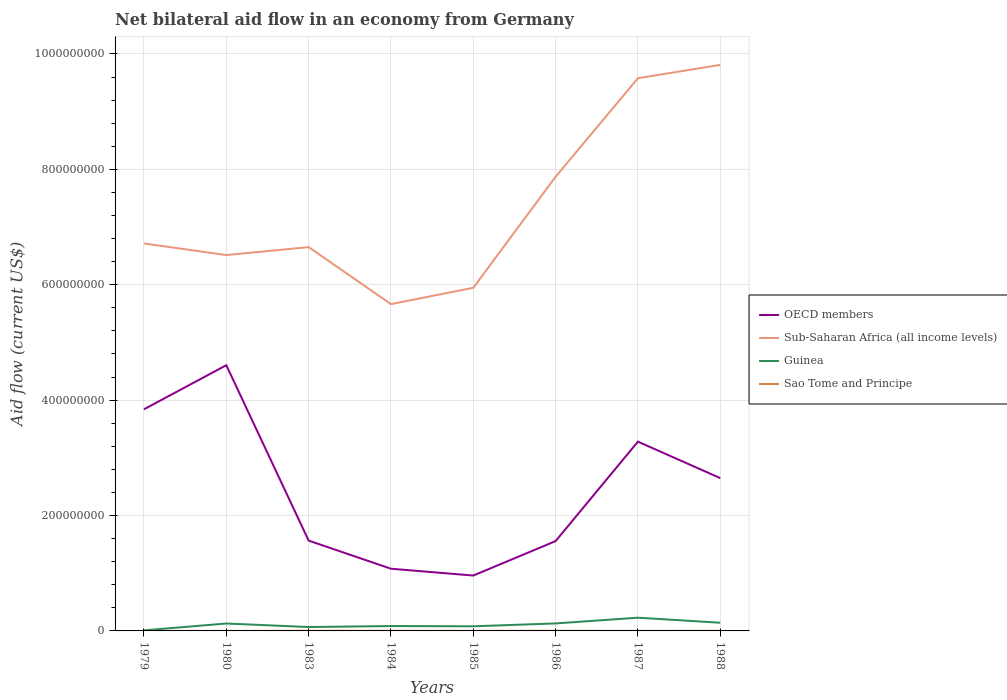How many different coloured lines are there?
Your answer should be compact. 4. Is the number of lines equal to the number of legend labels?
Keep it short and to the point. Yes. Across all years, what is the maximum net bilateral aid flow in Sub-Saharan Africa (all income levels)?
Your answer should be very brief. 5.66e+08. What is the total net bilateral aid flow in Sao Tome and Principe in the graph?
Offer a very short reply. -8.00e+04. What is the difference between the highest and the second highest net bilateral aid flow in Sao Tome and Principe?
Make the answer very short. 2.60e+05. How many lines are there?
Offer a terse response. 4. What is the difference between two consecutive major ticks on the Y-axis?
Offer a very short reply. 2.00e+08. Are the values on the major ticks of Y-axis written in scientific E-notation?
Offer a very short reply. No. Does the graph contain any zero values?
Offer a very short reply. No. Where does the legend appear in the graph?
Ensure brevity in your answer.  Center right. What is the title of the graph?
Offer a very short reply. Net bilateral aid flow in an economy from Germany. What is the Aid flow (current US$) in OECD members in 1979?
Offer a terse response. 3.84e+08. What is the Aid flow (current US$) in Sub-Saharan Africa (all income levels) in 1979?
Give a very brief answer. 6.71e+08. What is the Aid flow (current US$) in Sao Tome and Principe in 1979?
Provide a short and direct response. 4.00e+04. What is the Aid flow (current US$) in OECD members in 1980?
Provide a short and direct response. 4.61e+08. What is the Aid flow (current US$) in Sub-Saharan Africa (all income levels) in 1980?
Keep it short and to the point. 6.51e+08. What is the Aid flow (current US$) in Guinea in 1980?
Give a very brief answer. 1.28e+07. What is the Aid flow (current US$) in Sao Tome and Principe in 1980?
Your answer should be compact. 6.00e+04. What is the Aid flow (current US$) in OECD members in 1983?
Your answer should be very brief. 1.57e+08. What is the Aid flow (current US$) in Sub-Saharan Africa (all income levels) in 1983?
Provide a succinct answer. 6.65e+08. What is the Aid flow (current US$) of Guinea in 1983?
Ensure brevity in your answer.  6.73e+06. What is the Aid flow (current US$) of Sao Tome and Principe in 1983?
Offer a very short reply. 2.20e+05. What is the Aid flow (current US$) in OECD members in 1984?
Your answer should be compact. 1.08e+08. What is the Aid flow (current US$) of Sub-Saharan Africa (all income levels) in 1984?
Ensure brevity in your answer.  5.66e+08. What is the Aid flow (current US$) of Guinea in 1984?
Provide a succinct answer. 8.46e+06. What is the Aid flow (current US$) in Sao Tome and Principe in 1984?
Your response must be concise. 2.50e+05. What is the Aid flow (current US$) in OECD members in 1985?
Provide a succinct answer. 9.60e+07. What is the Aid flow (current US$) of Sub-Saharan Africa (all income levels) in 1985?
Make the answer very short. 5.95e+08. What is the Aid flow (current US$) in Guinea in 1985?
Provide a short and direct response. 8.01e+06. What is the Aid flow (current US$) of Sao Tome and Principe in 1985?
Provide a short and direct response. 9.00e+04. What is the Aid flow (current US$) of OECD members in 1986?
Offer a terse response. 1.56e+08. What is the Aid flow (current US$) of Sub-Saharan Africa (all income levels) in 1986?
Give a very brief answer. 7.87e+08. What is the Aid flow (current US$) of Guinea in 1986?
Ensure brevity in your answer.  1.30e+07. What is the Aid flow (current US$) of OECD members in 1987?
Your answer should be compact. 3.28e+08. What is the Aid flow (current US$) in Sub-Saharan Africa (all income levels) in 1987?
Your answer should be very brief. 9.58e+08. What is the Aid flow (current US$) of Guinea in 1987?
Offer a terse response. 2.29e+07. What is the Aid flow (current US$) of OECD members in 1988?
Give a very brief answer. 2.65e+08. What is the Aid flow (current US$) of Sub-Saharan Africa (all income levels) in 1988?
Give a very brief answer. 9.81e+08. What is the Aid flow (current US$) in Guinea in 1988?
Make the answer very short. 1.42e+07. What is the Aid flow (current US$) in Sao Tome and Principe in 1988?
Your response must be concise. 3.00e+05. Across all years, what is the maximum Aid flow (current US$) of OECD members?
Provide a short and direct response. 4.61e+08. Across all years, what is the maximum Aid flow (current US$) of Sub-Saharan Africa (all income levels)?
Offer a terse response. 9.81e+08. Across all years, what is the maximum Aid flow (current US$) of Guinea?
Your answer should be compact. 2.29e+07. Across all years, what is the maximum Aid flow (current US$) of Sao Tome and Principe?
Provide a succinct answer. 3.00e+05. Across all years, what is the minimum Aid flow (current US$) in OECD members?
Offer a very short reply. 9.60e+07. Across all years, what is the minimum Aid flow (current US$) of Sub-Saharan Africa (all income levels)?
Your answer should be compact. 5.66e+08. Across all years, what is the minimum Aid flow (current US$) in Sao Tome and Principe?
Provide a succinct answer. 4.00e+04. What is the total Aid flow (current US$) in OECD members in the graph?
Provide a succinct answer. 1.95e+09. What is the total Aid flow (current US$) in Sub-Saharan Africa (all income levels) in the graph?
Provide a short and direct response. 5.88e+09. What is the total Aid flow (current US$) of Guinea in the graph?
Your response must be concise. 8.72e+07. What is the total Aid flow (current US$) of Sao Tome and Principe in the graph?
Give a very brief answer. 1.29e+06. What is the difference between the Aid flow (current US$) of OECD members in 1979 and that in 1980?
Your answer should be very brief. -7.64e+07. What is the difference between the Aid flow (current US$) of Sub-Saharan Africa (all income levels) in 1979 and that in 1980?
Your response must be concise. 2.01e+07. What is the difference between the Aid flow (current US$) of Guinea in 1979 and that in 1980?
Your response must be concise. -1.18e+07. What is the difference between the Aid flow (current US$) of OECD members in 1979 and that in 1983?
Your answer should be compact. 2.28e+08. What is the difference between the Aid flow (current US$) in Sub-Saharan Africa (all income levels) in 1979 and that in 1983?
Offer a very short reply. 6.29e+06. What is the difference between the Aid flow (current US$) of Guinea in 1979 and that in 1983?
Provide a succinct answer. -5.73e+06. What is the difference between the Aid flow (current US$) of OECD members in 1979 and that in 1984?
Make the answer very short. 2.76e+08. What is the difference between the Aid flow (current US$) of Sub-Saharan Africa (all income levels) in 1979 and that in 1984?
Ensure brevity in your answer.  1.05e+08. What is the difference between the Aid flow (current US$) in Guinea in 1979 and that in 1984?
Offer a terse response. -7.46e+06. What is the difference between the Aid flow (current US$) in OECD members in 1979 and that in 1985?
Offer a terse response. 2.88e+08. What is the difference between the Aid flow (current US$) of Sub-Saharan Africa (all income levels) in 1979 and that in 1985?
Your answer should be very brief. 7.68e+07. What is the difference between the Aid flow (current US$) in Guinea in 1979 and that in 1985?
Provide a succinct answer. -7.01e+06. What is the difference between the Aid flow (current US$) of Sao Tome and Principe in 1979 and that in 1985?
Keep it short and to the point. -5.00e+04. What is the difference between the Aid flow (current US$) in OECD members in 1979 and that in 1986?
Ensure brevity in your answer.  2.28e+08. What is the difference between the Aid flow (current US$) of Sub-Saharan Africa (all income levels) in 1979 and that in 1986?
Your response must be concise. -1.16e+08. What is the difference between the Aid flow (current US$) in Guinea in 1979 and that in 1986?
Provide a succinct answer. -1.20e+07. What is the difference between the Aid flow (current US$) in OECD members in 1979 and that in 1987?
Offer a terse response. 5.61e+07. What is the difference between the Aid flow (current US$) of Sub-Saharan Africa (all income levels) in 1979 and that in 1987?
Provide a short and direct response. -2.86e+08. What is the difference between the Aid flow (current US$) in Guinea in 1979 and that in 1987?
Ensure brevity in your answer.  -2.19e+07. What is the difference between the Aid flow (current US$) of OECD members in 1979 and that in 1988?
Give a very brief answer. 1.19e+08. What is the difference between the Aid flow (current US$) in Sub-Saharan Africa (all income levels) in 1979 and that in 1988?
Provide a short and direct response. -3.10e+08. What is the difference between the Aid flow (current US$) of Guinea in 1979 and that in 1988?
Give a very brief answer. -1.32e+07. What is the difference between the Aid flow (current US$) of Sao Tome and Principe in 1979 and that in 1988?
Provide a succinct answer. -2.60e+05. What is the difference between the Aid flow (current US$) of OECD members in 1980 and that in 1983?
Your answer should be compact. 3.04e+08. What is the difference between the Aid flow (current US$) of Sub-Saharan Africa (all income levels) in 1980 and that in 1983?
Give a very brief answer. -1.38e+07. What is the difference between the Aid flow (current US$) in Guinea in 1980 and that in 1983?
Make the answer very short. 6.12e+06. What is the difference between the Aid flow (current US$) of Sao Tome and Principe in 1980 and that in 1983?
Provide a succinct answer. -1.60e+05. What is the difference between the Aid flow (current US$) in OECD members in 1980 and that in 1984?
Give a very brief answer. 3.53e+08. What is the difference between the Aid flow (current US$) of Sub-Saharan Africa (all income levels) in 1980 and that in 1984?
Offer a very short reply. 8.50e+07. What is the difference between the Aid flow (current US$) in Guinea in 1980 and that in 1984?
Your response must be concise. 4.39e+06. What is the difference between the Aid flow (current US$) in Sao Tome and Principe in 1980 and that in 1984?
Provide a short and direct response. -1.90e+05. What is the difference between the Aid flow (current US$) in OECD members in 1980 and that in 1985?
Keep it short and to the point. 3.65e+08. What is the difference between the Aid flow (current US$) in Sub-Saharan Africa (all income levels) in 1980 and that in 1985?
Make the answer very short. 5.67e+07. What is the difference between the Aid flow (current US$) of Guinea in 1980 and that in 1985?
Provide a short and direct response. 4.84e+06. What is the difference between the Aid flow (current US$) of Sao Tome and Principe in 1980 and that in 1985?
Ensure brevity in your answer.  -3.00e+04. What is the difference between the Aid flow (current US$) in OECD members in 1980 and that in 1986?
Provide a short and direct response. 3.05e+08. What is the difference between the Aid flow (current US$) of Sub-Saharan Africa (all income levels) in 1980 and that in 1986?
Give a very brief answer. -1.36e+08. What is the difference between the Aid flow (current US$) in OECD members in 1980 and that in 1987?
Ensure brevity in your answer.  1.32e+08. What is the difference between the Aid flow (current US$) of Sub-Saharan Africa (all income levels) in 1980 and that in 1987?
Provide a succinct answer. -3.07e+08. What is the difference between the Aid flow (current US$) of Guinea in 1980 and that in 1987?
Keep it short and to the point. -1.01e+07. What is the difference between the Aid flow (current US$) of OECD members in 1980 and that in 1988?
Ensure brevity in your answer.  1.96e+08. What is the difference between the Aid flow (current US$) in Sub-Saharan Africa (all income levels) in 1980 and that in 1988?
Ensure brevity in your answer.  -3.30e+08. What is the difference between the Aid flow (current US$) in Guinea in 1980 and that in 1988?
Give a very brief answer. -1.35e+06. What is the difference between the Aid flow (current US$) of Sao Tome and Principe in 1980 and that in 1988?
Your response must be concise. -2.40e+05. What is the difference between the Aid flow (current US$) of OECD members in 1983 and that in 1984?
Provide a short and direct response. 4.87e+07. What is the difference between the Aid flow (current US$) of Sub-Saharan Africa (all income levels) in 1983 and that in 1984?
Your answer should be compact. 9.88e+07. What is the difference between the Aid flow (current US$) in Guinea in 1983 and that in 1984?
Your answer should be very brief. -1.73e+06. What is the difference between the Aid flow (current US$) in OECD members in 1983 and that in 1985?
Your response must be concise. 6.06e+07. What is the difference between the Aid flow (current US$) of Sub-Saharan Africa (all income levels) in 1983 and that in 1985?
Provide a short and direct response. 7.05e+07. What is the difference between the Aid flow (current US$) in Guinea in 1983 and that in 1985?
Your answer should be compact. -1.28e+06. What is the difference between the Aid flow (current US$) in Sao Tome and Principe in 1983 and that in 1985?
Offer a very short reply. 1.30e+05. What is the difference between the Aid flow (current US$) in OECD members in 1983 and that in 1986?
Your answer should be very brief. 8.70e+05. What is the difference between the Aid flow (current US$) of Sub-Saharan Africa (all income levels) in 1983 and that in 1986?
Your answer should be compact. -1.22e+08. What is the difference between the Aid flow (current US$) of Guinea in 1983 and that in 1986?
Make the answer very short. -6.25e+06. What is the difference between the Aid flow (current US$) of OECD members in 1983 and that in 1987?
Ensure brevity in your answer.  -1.72e+08. What is the difference between the Aid flow (current US$) in Sub-Saharan Africa (all income levels) in 1983 and that in 1987?
Keep it short and to the point. -2.93e+08. What is the difference between the Aid flow (current US$) of Guinea in 1983 and that in 1987?
Keep it short and to the point. -1.62e+07. What is the difference between the Aid flow (current US$) in Sao Tome and Principe in 1983 and that in 1987?
Keep it short and to the point. 1.70e+05. What is the difference between the Aid flow (current US$) of OECD members in 1983 and that in 1988?
Provide a short and direct response. -1.08e+08. What is the difference between the Aid flow (current US$) of Sub-Saharan Africa (all income levels) in 1983 and that in 1988?
Make the answer very short. -3.16e+08. What is the difference between the Aid flow (current US$) in Guinea in 1983 and that in 1988?
Your response must be concise. -7.47e+06. What is the difference between the Aid flow (current US$) of Sao Tome and Principe in 1983 and that in 1988?
Your answer should be very brief. -8.00e+04. What is the difference between the Aid flow (current US$) of OECD members in 1984 and that in 1985?
Offer a very short reply. 1.18e+07. What is the difference between the Aid flow (current US$) of Sub-Saharan Africa (all income levels) in 1984 and that in 1985?
Provide a short and direct response. -2.82e+07. What is the difference between the Aid flow (current US$) in Sao Tome and Principe in 1984 and that in 1985?
Your response must be concise. 1.60e+05. What is the difference between the Aid flow (current US$) of OECD members in 1984 and that in 1986?
Provide a succinct answer. -4.79e+07. What is the difference between the Aid flow (current US$) in Sub-Saharan Africa (all income levels) in 1984 and that in 1986?
Your response must be concise. -2.21e+08. What is the difference between the Aid flow (current US$) of Guinea in 1984 and that in 1986?
Offer a very short reply. -4.52e+06. What is the difference between the Aid flow (current US$) of Sao Tome and Principe in 1984 and that in 1986?
Your response must be concise. -3.00e+04. What is the difference between the Aid flow (current US$) of OECD members in 1984 and that in 1987?
Offer a terse response. -2.20e+08. What is the difference between the Aid flow (current US$) of Sub-Saharan Africa (all income levels) in 1984 and that in 1987?
Offer a terse response. -3.92e+08. What is the difference between the Aid flow (current US$) of Guinea in 1984 and that in 1987?
Offer a very short reply. -1.45e+07. What is the difference between the Aid flow (current US$) in OECD members in 1984 and that in 1988?
Your answer should be compact. -1.57e+08. What is the difference between the Aid flow (current US$) of Sub-Saharan Africa (all income levels) in 1984 and that in 1988?
Make the answer very short. -4.15e+08. What is the difference between the Aid flow (current US$) of Guinea in 1984 and that in 1988?
Offer a very short reply. -5.74e+06. What is the difference between the Aid flow (current US$) in OECD members in 1985 and that in 1986?
Your answer should be very brief. -5.97e+07. What is the difference between the Aid flow (current US$) of Sub-Saharan Africa (all income levels) in 1985 and that in 1986?
Keep it short and to the point. -1.93e+08. What is the difference between the Aid flow (current US$) of Guinea in 1985 and that in 1986?
Provide a succinct answer. -4.97e+06. What is the difference between the Aid flow (current US$) of OECD members in 1985 and that in 1987?
Your response must be concise. -2.32e+08. What is the difference between the Aid flow (current US$) of Sub-Saharan Africa (all income levels) in 1985 and that in 1987?
Make the answer very short. -3.63e+08. What is the difference between the Aid flow (current US$) of Guinea in 1985 and that in 1987?
Keep it short and to the point. -1.49e+07. What is the difference between the Aid flow (current US$) in OECD members in 1985 and that in 1988?
Give a very brief answer. -1.69e+08. What is the difference between the Aid flow (current US$) in Sub-Saharan Africa (all income levels) in 1985 and that in 1988?
Your answer should be very brief. -3.86e+08. What is the difference between the Aid flow (current US$) in Guinea in 1985 and that in 1988?
Provide a short and direct response. -6.19e+06. What is the difference between the Aid flow (current US$) in OECD members in 1986 and that in 1987?
Your answer should be compact. -1.72e+08. What is the difference between the Aid flow (current US$) in Sub-Saharan Africa (all income levels) in 1986 and that in 1987?
Your answer should be very brief. -1.71e+08. What is the difference between the Aid flow (current US$) in Guinea in 1986 and that in 1987?
Offer a very short reply. -9.94e+06. What is the difference between the Aid flow (current US$) in OECD members in 1986 and that in 1988?
Offer a terse response. -1.09e+08. What is the difference between the Aid flow (current US$) in Sub-Saharan Africa (all income levels) in 1986 and that in 1988?
Your answer should be very brief. -1.94e+08. What is the difference between the Aid flow (current US$) of Guinea in 1986 and that in 1988?
Keep it short and to the point. -1.22e+06. What is the difference between the Aid flow (current US$) of Sao Tome and Principe in 1986 and that in 1988?
Keep it short and to the point. -2.00e+04. What is the difference between the Aid flow (current US$) of OECD members in 1987 and that in 1988?
Your response must be concise. 6.32e+07. What is the difference between the Aid flow (current US$) in Sub-Saharan Africa (all income levels) in 1987 and that in 1988?
Make the answer very short. -2.31e+07. What is the difference between the Aid flow (current US$) of Guinea in 1987 and that in 1988?
Provide a short and direct response. 8.72e+06. What is the difference between the Aid flow (current US$) of OECD members in 1979 and the Aid flow (current US$) of Sub-Saharan Africa (all income levels) in 1980?
Offer a very short reply. -2.67e+08. What is the difference between the Aid flow (current US$) of OECD members in 1979 and the Aid flow (current US$) of Guinea in 1980?
Give a very brief answer. 3.71e+08. What is the difference between the Aid flow (current US$) in OECD members in 1979 and the Aid flow (current US$) in Sao Tome and Principe in 1980?
Keep it short and to the point. 3.84e+08. What is the difference between the Aid flow (current US$) in Sub-Saharan Africa (all income levels) in 1979 and the Aid flow (current US$) in Guinea in 1980?
Your response must be concise. 6.59e+08. What is the difference between the Aid flow (current US$) of Sub-Saharan Africa (all income levels) in 1979 and the Aid flow (current US$) of Sao Tome and Principe in 1980?
Your answer should be compact. 6.71e+08. What is the difference between the Aid flow (current US$) in Guinea in 1979 and the Aid flow (current US$) in Sao Tome and Principe in 1980?
Your answer should be very brief. 9.40e+05. What is the difference between the Aid flow (current US$) of OECD members in 1979 and the Aid flow (current US$) of Sub-Saharan Africa (all income levels) in 1983?
Your response must be concise. -2.81e+08. What is the difference between the Aid flow (current US$) in OECD members in 1979 and the Aid flow (current US$) in Guinea in 1983?
Offer a terse response. 3.77e+08. What is the difference between the Aid flow (current US$) in OECD members in 1979 and the Aid flow (current US$) in Sao Tome and Principe in 1983?
Your answer should be very brief. 3.84e+08. What is the difference between the Aid flow (current US$) of Sub-Saharan Africa (all income levels) in 1979 and the Aid flow (current US$) of Guinea in 1983?
Keep it short and to the point. 6.65e+08. What is the difference between the Aid flow (current US$) of Sub-Saharan Africa (all income levels) in 1979 and the Aid flow (current US$) of Sao Tome and Principe in 1983?
Offer a very short reply. 6.71e+08. What is the difference between the Aid flow (current US$) of Guinea in 1979 and the Aid flow (current US$) of Sao Tome and Principe in 1983?
Your answer should be very brief. 7.80e+05. What is the difference between the Aid flow (current US$) of OECD members in 1979 and the Aid flow (current US$) of Sub-Saharan Africa (all income levels) in 1984?
Your answer should be compact. -1.82e+08. What is the difference between the Aid flow (current US$) of OECD members in 1979 and the Aid flow (current US$) of Guinea in 1984?
Your response must be concise. 3.76e+08. What is the difference between the Aid flow (current US$) of OECD members in 1979 and the Aid flow (current US$) of Sao Tome and Principe in 1984?
Offer a terse response. 3.84e+08. What is the difference between the Aid flow (current US$) of Sub-Saharan Africa (all income levels) in 1979 and the Aid flow (current US$) of Guinea in 1984?
Offer a very short reply. 6.63e+08. What is the difference between the Aid flow (current US$) of Sub-Saharan Africa (all income levels) in 1979 and the Aid flow (current US$) of Sao Tome and Principe in 1984?
Your response must be concise. 6.71e+08. What is the difference between the Aid flow (current US$) in Guinea in 1979 and the Aid flow (current US$) in Sao Tome and Principe in 1984?
Provide a succinct answer. 7.50e+05. What is the difference between the Aid flow (current US$) in OECD members in 1979 and the Aid flow (current US$) in Sub-Saharan Africa (all income levels) in 1985?
Offer a terse response. -2.11e+08. What is the difference between the Aid flow (current US$) in OECD members in 1979 and the Aid flow (current US$) in Guinea in 1985?
Give a very brief answer. 3.76e+08. What is the difference between the Aid flow (current US$) in OECD members in 1979 and the Aid flow (current US$) in Sao Tome and Principe in 1985?
Provide a short and direct response. 3.84e+08. What is the difference between the Aid flow (current US$) of Sub-Saharan Africa (all income levels) in 1979 and the Aid flow (current US$) of Guinea in 1985?
Make the answer very short. 6.63e+08. What is the difference between the Aid flow (current US$) of Sub-Saharan Africa (all income levels) in 1979 and the Aid flow (current US$) of Sao Tome and Principe in 1985?
Make the answer very short. 6.71e+08. What is the difference between the Aid flow (current US$) of Guinea in 1979 and the Aid flow (current US$) of Sao Tome and Principe in 1985?
Provide a short and direct response. 9.10e+05. What is the difference between the Aid flow (current US$) of OECD members in 1979 and the Aid flow (current US$) of Sub-Saharan Africa (all income levels) in 1986?
Give a very brief answer. -4.03e+08. What is the difference between the Aid flow (current US$) in OECD members in 1979 and the Aid flow (current US$) in Guinea in 1986?
Keep it short and to the point. 3.71e+08. What is the difference between the Aid flow (current US$) of OECD members in 1979 and the Aid flow (current US$) of Sao Tome and Principe in 1986?
Your answer should be very brief. 3.84e+08. What is the difference between the Aid flow (current US$) of Sub-Saharan Africa (all income levels) in 1979 and the Aid flow (current US$) of Guinea in 1986?
Ensure brevity in your answer.  6.59e+08. What is the difference between the Aid flow (current US$) in Sub-Saharan Africa (all income levels) in 1979 and the Aid flow (current US$) in Sao Tome and Principe in 1986?
Provide a succinct answer. 6.71e+08. What is the difference between the Aid flow (current US$) of Guinea in 1979 and the Aid flow (current US$) of Sao Tome and Principe in 1986?
Ensure brevity in your answer.  7.20e+05. What is the difference between the Aid flow (current US$) of OECD members in 1979 and the Aid flow (current US$) of Sub-Saharan Africa (all income levels) in 1987?
Offer a very short reply. -5.74e+08. What is the difference between the Aid flow (current US$) in OECD members in 1979 and the Aid flow (current US$) in Guinea in 1987?
Make the answer very short. 3.61e+08. What is the difference between the Aid flow (current US$) of OECD members in 1979 and the Aid flow (current US$) of Sao Tome and Principe in 1987?
Give a very brief answer. 3.84e+08. What is the difference between the Aid flow (current US$) of Sub-Saharan Africa (all income levels) in 1979 and the Aid flow (current US$) of Guinea in 1987?
Offer a very short reply. 6.49e+08. What is the difference between the Aid flow (current US$) in Sub-Saharan Africa (all income levels) in 1979 and the Aid flow (current US$) in Sao Tome and Principe in 1987?
Your answer should be very brief. 6.71e+08. What is the difference between the Aid flow (current US$) of Guinea in 1979 and the Aid flow (current US$) of Sao Tome and Principe in 1987?
Keep it short and to the point. 9.50e+05. What is the difference between the Aid flow (current US$) in OECD members in 1979 and the Aid flow (current US$) in Sub-Saharan Africa (all income levels) in 1988?
Your answer should be very brief. -5.97e+08. What is the difference between the Aid flow (current US$) in OECD members in 1979 and the Aid flow (current US$) in Guinea in 1988?
Make the answer very short. 3.70e+08. What is the difference between the Aid flow (current US$) of OECD members in 1979 and the Aid flow (current US$) of Sao Tome and Principe in 1988?
Provide a succinct answer. 3.84e+08. What is the difference between the Aid flow (current US$) in Sub-Saharan Africa (all income levels) in 1979 and the Aid flow (current US$) in Guinea in 1988?
Your answer should be compact. 6.57e+08. What is the difference between the Aid flow (current US$) of Sub-Saharan Africa (all income levels) in 1979 and the Aid flow (current US$) of Sao Tome and Principe in 1988?
Offer a very short reply. 6.71e+08. What is the difference between the Aid flow (current US$) of Guinea in 1979 and the Aid flow (current US$) of Sao Tome and Principe in 1988?
Make the answer very short. 7.00e+05. What is the difference between the Aid flow (current US$) in OECD members in 1980 and the Aid flow (current US$) in Sub-Saharan Africa (all income levels) in 1983?
Your answer should be very brief. -2.05e+08. What is the difference between the Aid flow (current US$) in OECD members in 1980 and the Aid flow (current US$) in Guinea in 1983?
Give a very brief answer. 4.54e+08. What is the difference between the Aid flow (current US$) in OECD members in 1980 and the Aid flow (current US$) in Sao Tome and Principe in 1983?
Your answer should be very brief. 4.60e+08. What is the difference between the Aid flow (current US$) of Sub-Saharan Africa (all income levels) in 1980 and the Aid flow (current US$) of Guinea in 1983?
Your answer should be compact. 6.45e+08. What is the difference between the Aid flow (current US$) of Sub-Saharan Africa (all income levels) in 1980 and the Aid flow (current US$) of Sao Tome and Principe in 1983?
Keep it short and to the point. 6.51e+08. What is the difference between the Aid flow (current US$) of Guinea in 1980 and the Aid flow (current US$) of Sao Tome and Principe in 1983?
Give a very brief answer. 1.26e+07. What is the difference between the Aid flow (current US$) of OECD members in 1980 and the Aid flow (current US$) of Sub-Saharan Africa (all income levels) in 1984?
Your answer should be very brief. -1.06e+08. What is the difference between the Aid flow (current US$) of OECD members in 1980 and the Aid flow (current US$) of Guinea in 1984?
Your answer should be very brief. 4.52e+08. What is the difference between the Aid flow (current US$) in OECD members in 1980 and the Aid flow (current US$) in Sao Tome and Principe in 1984?
Provide a succinct answer. 4.60e+08. What is the difference between the Aid flow (current US$) of Sub-Saharan Africa (all income levels) in 1980 and the Aid flow (current US$) of Guinea in 1984?
Your response must be concise. 6.43e+08. What is the difference between the Aid flow (current US$) of Sub-Saharan Africa (all income levels) in 1980 and the Aid flow (current US$) of Sao Tome and Principe in 1984?
Keep it short and to the point. 6.51e+08. What is the difference between the Aid flow (current US$) in Guinea in 1980 and the Aid flow (current US$) in Sao Tome and Principe in 1984?
Offer a very short reply. 1.26e+07. What is the difference between the Aid flow (current US$) of OECD members in 1980 and the Aid flow (current US$) of Sub-Saharan Africa (all income levels) in 1985?
Offer a very short reply. -1.34e+08. What is the difference between the Aid flow (current US$) in OECD members in 1980 and the Aid flow (current US$) in Guinea in 1985?
Provide a short and direct response. 4.52e+08. What is the difference between the Aid flow (current US$) in OECD members in 1980 and the Aid flow (current US$) in Sao Tome and Principe in 1985?
Give a very brief answer. 4.60e+08. What is the difference between the Aid flow (current US$) of Sub-Saharan Africa (all income levels) in 1980 and the Aid flow (current US$) of Guinea in 1985?
Your response must be concise. 6.43e+08. What is the difference between the Aid flow (current US$) in Sub-Saharan Africa (all income levels) in 1980 and the Aid flow (current US$) in Sao Tome and Principe in 1985?
Offer a very short reply. 6.51e+08. What is the difference between the Aid flow (current US$) of Guinea in 1980 and the Aid flow (current US$) of Sao Tome and Principe in 1985?
Your response must be concise. 1.28e+07. What is the difference between the Aid flow (current US$) in OECD members in 1980 and the Aid flow (current US$) in Sub-Saharan Africa (all income levels) in 1986?
Give a very brief answer. -3.27e+08. What is the difference between the Aid flow (current US$) in OECD members in 1980 and the Aid flow (current US$) in Guinea in 1986?
Provide a succinct answer. 4.48e+08. What is the difference between the Aid flow (current US$) of OECD members in 1980 and the Aid flow (current US$) of Sao Tome and Principe in 1986?
Give a very brief answer. 4.60e+08. What is the difference between the Aid flow (current US$) in Sub-Saharan Africa (all income levels) in 1980 and the Aid flow (current US$) in Guinea in 1986?
Your response must be concise. 6.38e+08. What is the difference between the Aid flow (current US$) in Sub-Saharan Africa (all income levels) in 1980 and the Aid flow (current US$) in Sao Tome and Principe in 1986?
Your response must be concise. 6.51e+08. What is the difference between the Aid flow (current US$) of Guinea in 1980 and the Aid flow (current US$) of Sao Tome and Principe in 1986?
Keep it short and to the point. 1.26e+07. What is the difference between the Aid flow (current US$) of OECD members in 1980 and the Aid flow (current US$) of Sub-Saharan Africa (all income levels) in 1987?
Give a very brief answer. -4.97e+08. What is the difference between the Aid flow (current US$) in OECD members in 1980 and the Aid flow (current US$) in Guinea in 1987?
Provide a short and direct response. 4.38e+08. What is the difference between the Aid flow (current US$) of OECD members in 1980 and the Aid flow (current US$) of Sao Tome and Principe in 1987?
Your answer should be compact. 4.60e+08. What is the difference between the Aid flow (current US$) of Sub-Saharan Africa (all income levels) in 1980 and the Aid flow (current US$) of Guinea in 1987?
Make the answer very short. 6.28e+08. What is the difference between the Aid flow (current US$) in Sub-Saharan Africa (all income levels) in 1980 and the Aid flow (current US$) in Sao Tome and Principe in 1987?
Keep it short and to the point. 6.51e+08. What is the difference between the Aid flow (current US$) of Guinea in 1980 and the Aid flow (current US$) of Sao Tome and Principe in 1987?
Your answer should be very brief. 1.28e+07. What is the difference between the Aid flow (current US$) in OECD members in 1980 and the Aid flow (current US$) in Sub-Saharan Africa (all income levels) in 1988?
Your answer should be very brief. -5.21e+08. What is the difference between the Aid flow (current US$) in OECD members in 1980 and the Aid flow (current US$) in Guinea in 1988?
Your response must be concise. 4.46e+08. What is the difference between the Aid flow (current US$) of OECD members in 1980 and the Aid flow (current US$) of Sao Tome and Principe in 1988?
Your answer should be compact. 4.60e+08. What is the difference between the Aid flow (current US$) in Sub-Saharan Africa (all income levels) in 1980 and the Aid flow (current US$) in Guinea in 1988?
Offer a terse response. 6.37e+08. What is the difference between the Aid flow (current US$) of Sub-Saharan Africa (all income levels) in 1980 and the Aid flow (current US$) of Sao Tome and Principe in 1988?
Make the answer very short. 6.51e+08. What is the difference between the Aid flow (current US$) of Guinea in 1980 and the Aid flow (current US$) of Sao Tome and Principe in 1988?
Keep it short and to the point. 1.26e+07. What is the difference between the Aid flow (current US$) in OECD members in 1983 and the Aid flow (current US$) in Sub-Saharan Africa (all income levels) in 1984?
Provide a succinct answer. -4.10e+08. What is the difference between the Aid flow (current US$) in OECD members in 1983 and the Aid flow (current US$) in Guinea in 1984?
Make the answer very short. 1.48e+08. What is the difference between the Aid flow (current US$) in OECD members in 1983 and the Aid flow (current US$) in Sao Tome and Principe in 1984?
Offer a terse response. 1.56e+08. What is the difference between the Aid flow (current US$) of Sub-Saharan Africa (all income levels) in 1983 and the Aid flow (current US$) of Guinea in 1984?
Give a very brief answer. 6.57e+08. What is the difference between the Aid flow (current US$) of Sub-Saharan Africa (all income levels) in 1983 and the Aid flow (current US$) of Sao Tome and Principe in 1984?
Offer a terse response. 6.65e+08. What is the difference between the Aid flow (current US$) of Guinea in 1983 and the Aid flow (current US$) of Sao Tome and Principe in 1984?
Your answer should be very brief. 6.48e+06. What is the difference between the Aid flow (current US$) in OECD members in 1983 and the Aid flow (current US$) in Sub-Saharan Africa (all income levels) in 1985?
Your answer should be compact. -4.38e+08. What is the difference between the Aid flow (current US$) in OECD members in 1983 and the Aid flow (current US$) in Guinea in 1985?
Offer a terse response. 1.49e+08. What is the difference between the Aid flow (current US$) of OECD members in 1983 and the Aid flow (current US$) of Sao Tome and Principe in 1985?
Offer a very short reply. 1.56e+08. What is the difference between the Aid flow (current US$) of Sub-Saharan Africa (all income levels) in 1983 and the Aid flow (current US$) of Guinea in 1985?
Your response must be concise. 6.57e+08. What is the difference between the Aid flow (current US$) in Sub-Saharan Africa (all income levels) in 1983 and the Aid flow (current US$) in Sao Tome and Principe in 1985?
Your answer should be very brief. 6.65e+08. What is the difference between the Aid flow (current US$) in Guinea in 1983 and the Aid flow (current US$) in Sao Tome and Principe in 1985?
Your answer should be compact. 6.64e+06. What is the difference between the Aid flow (current US$) of OECD members in 1983 and the Aid flow (current US$) of Sub-Saharan Africa (all income levels) in 1986?
Offer a terse response. -6.31e+08. What is the difference between the Aid flow (current US$) in OECD members in 1983 and the Aid flow (current US$) in Guinea in 1986?
Your answer should be very brief. 1.44e+08. What is the difference between the Aid flow (current US$) of OECD members in 1983 and the Aid flow (current US$) of Sao Tome and Principe in 1986?
Your response must be concise. 1.56e+08. What is the difference between the Aid flow (current US$) in Sub-Saharan Africa (all income levels) in 1983 and the Aid flow (current US$) in Guinea in 1986?
Make the answer very short. 6.52e+08. What is the difference between the Aid flow (current US$) of Sub-Saharan Africa (all income levels) in 1983 and the Aid flow (current US$) of Sao Tome and Principe in 1986?
Ensure brevity in your answer.  6.65e+08. What is the difference between the Aid flow (current US$) in Guinea in 1983 and the Aid flow (current US$) in Sao Tome and Principe in 1986?
Offer a very short reply. 6.45e+06. What is the difference between the Aid flow (current US$) of OECD members in 1983 and the Aid flow (current US$) of Sub-Saharan Africa (all income levels) in 1987?
Provide a short and direct response. -8.01e+08. What is the difference between the Aid flow (current US$) of OECD members in 1983 and the Aid flow (current US$) of Guinea in 1987?
Provide a succinct answer. 1.34e+08. What is the difference between the Aid flow (current US$) of OECD members in 1983 and the Aid flow (current US$) of Sao Tome and Principe in 1987?
Provide a short and direct response. 1.56e+08. What is the difference between the Aid flow (current US$) of Sub-Saharan Africa (all income levels) in 1983 and the Aid flow (current US$) of Guinea in 1987?
Give a very brief answer. 6.42e+08. What is the difference between the Aid flow (current US$) in Sub-Saharan Africa (all income levels) in 1983 and the Aid flow (current US$) in Sao Tome and Principe in 1987?
Ensure brevity in your answer.  6.65e+08. What is the difference between the Aid flow (current US$) in Guinea in 1983 and the Aid flow (current US$) in Sao Tome and Principe in 1987?
Keep it short and to the point. 6.68e+06. What is the difference between the Aid flow (current US$) in OECD members in 1983 and the Aid flow (current US$) in Sub-Saharan Africa (all income levels) in 1988?
Ensure brevity in your answer.  -8.25e+08. What is the difference between the Aid flow (current US$) in OECD members in 1983 and the Aid flow (current US$) in Guinea in 1988?
Your answer should be compact. 1.42e+08. What is the difference between the Aid flow (current US$) in OECD members in 1983 and the Aid flow (current US$) in Sao Tome and Principe in 1988?
Ensure brevity in your answer.  1.56e+08. What is the difference between the Aid flow (current US$) in Sub-Saharan Africa (all income levels) in 1983 and the Aid flow (current US$) in Guinea in 1988?
Give a very brief answer. 6.51e+08. What is the difference between the Aid flow (current US$) in Sub-Saharan Africa (all income levels) in 1983 and the Aid flow (current US$) in Sao Tome and Principe in 1988?
Your answer should be compact. 6.65e+08. What is the difference between the Aid flow (current US$) of Guinea in 1983 and the Aid flow (current US$) of Sao Tome and Principe in 1988?
Make the answer very short. 6.43e+06. What is the difference between the Aid flow (current US$) of OECD members in 1984 and the Aid flow (current US$) of Sub-Saharan Africa (all income levels) in 1985?
Offer a very short reply. -4.87e+08. What is the difference between the Aid flow (current US$) of OECD members in 1984 and the Aid flow (current US$) of Guinea in 1985?
Provide a short and direct response. 9.98e+07. What is the difference between the Aid flow (current US$) of OECD members in 1984 and the Aid flow (current US$) of Sao Tome and Principe in 1985?
Your response must be concise. 1.08e+08. What is the difference between the Aid flow (current US$) in Sub-Saharan Africa (all income levels) in 1984 and the Aid flow (current US$) in Guinea in 1985?
Keep it short and to the point. 5.58e+08. What is the difference between the Aid flow (current US$) of Sub-Saharan Africa (all income levels) in 1984 and the Aid flow (current US$) of Sao Tome and Principe in 1985?
Your response must be concise. 5.66e+08. What is the difference between the Aid flow (current US$) of Guinea in 1984 and the Aid flow (current US$) of Sao Tome and Principe in 1985?
Provide a succinct answer. 8.37e+06. What is the difference between the Aid flow (current US$) of OECD members in 1984 and the Aid flow (current US$) of Sub-Saharan Africa (all income levels) in 1986?
Your response must be concise. -6.79e+08. What is the difference between the Aid flow (current US$) of OECD members in 1984 and the Aid flow (current US$) of Guinea in 1986?
Offer a very short reply. 9.48e+07. What is the difference between the Aid flow (current US$) in OECD members in 1984 and the Aid flow (current US$) in Sao Tome and Principe in 1986?
Your answer should be compact. 1.08e+08. What is the difference between the Aid flow (current US$) of Sub-Saharan Africa (all income levels) in 1984 and the Aid flow (current US$) of Guinea in 1986?
Offer a very short reply. 5.53e+08. What is the difference between the Aid flow (current US$) in Sub-Saharan Africa (all income levels) in 1984 and the Aid flow (current US$) in Sao Tome and Principe in 1986?
Your answer should be compact. 5.66e+08. What is the difference between the Aid flow (current US$) of Guinea in 1984 and the Aid flow (current US$) of Sao Tome and Principe in 1986?
Offer a very short reply. 8.18e+06. What is the difference between the Aid flow (current US$) in OECD members in 1984 and the Aid flow (current US$) in Sub-Saharan Africa (all income levels) in 1987?
Your answer should be very brief. -8.50e+08. What is the difference between the Aid flow (current US$) of OECD members in 1984 and the Aid flow (current US$) of Guinea in 1987?
Ensure brevity in your answer.  8.49e+07. What is the difference between the Aid flow (current US$) of OECD members in 1984 and the Aid flow (current US$) of Sao Tome and Principe in 1987?
Provide a succinct answer. 1.08e+08. What is the difference between the Aid flow (current US$) in Sub-Saharan Africa (all income levels) in 1984 and the Aid flow (current US$) in Guinea in 1987?
Make the answer very short. 5.44e+08. What is the difference between the Aid flow (current US$) in Sub-Saharan Africa (all income levels) in 1984 and the Aid flow (current US$) in Sao Tome and Principe in 1987?
Your answer should be compact. 5.66e+08. What is the difference between the Aid flow (current US$) of Guinea in 1984 and the Aid flow (current US$) of Sao Tome and Principe in 1987?
Your answer should be compact. 8.41e+06. What is the difference between the Aid flow (current US$) of OECD members in 1984 and the Aid flow (current US$) of Sub-Saharan Africa (all income levels) in 1988?
Your response must be concise. -8.73e+08. What is the difference between the Aid flow (current US$) in OECD members in 1984 and the Aid flow (current US$) in Guinea in 1988?
Offer a terse response. 9.36e+07. What is the difference between the Aid flow (current US$) in OECD members in 1984 and the Aid flow (current US$) in Sao Tome and Principe in 1988?
Your answer should be very brief. 1.07e+08. What is the difference between the Aid flow (current US$) in Sub-Saharan Africa (all income levels) in 1984 and the Aid flow (current US$) in Guinea in 1988?
Offer a very short reply. 5.52e+08. What is the difference between the Aid flow (current US$) of Sub-Saharan Africa (all income levels) in 1984 and the Aid flow (current US$) of Sao Tome and Principe in 1988?
Provide a succinct answer. 5.66e+08. What is the difference between the Aid flow (current US$) in Guinea in 1984 and the Aid flow (current US$) in Sao Tome and Principe in 1988?
Offer a very short reply. 8.16e+06. What is the difference between the Aid flow (current US$) of OECD members in 1985 and the Aid flow (current US$) of Sub-Saharan Africa (all income levels) in 1986?
Provide a short and direct response. -6.91e+08. What is the difference between the Aid flow (current US$) of OECD members in 1985 and the Aid flow (current US$) of Guinea in 1986?
Offer a very short reply. 8.30e+07. What is the difference between the Aid flow (current US$) in OECD members in 1985 and the Aid flow (current US$) in Sao Tome and Principe in 1986?
Your answer should be compact. 9.57e+07. What is the difference between the Aid flow (current US$) in Sub-Saharan Africa (all income levels) in 1985 and the Aid flow (current US$) in Guinea in 1986?
Provide a short and direct response. 5.82e+08. What is the difference between the Aid flow (current US$) of Sub-Saharan Africa (all income levels) in 1985 and the Aid flow (current US$) of Sao Tome and Principe in 1986?
Give a very brief answer. 5.94e+08. What is the difference between the Aid flow (current US$) in Guinea in 1985 and the Aid flow (current US$) in Sao Tome and Principe in 1986?
Your response must be concise. 7.73e+06. What is the difference between the Aid flow (current US$) in OECD members in 1985 and the Aid flow (current US$) in Sub-Saharan Africa (all income levels) in 1987?
Offer a very short reply. -8.62e+08. What is the difference between the Aid flow (current US$) of OECD members in 1985 and the Aid flow (current US$) of Guinea in 1987?
Give a very brief answer. 7.31e+07. What is the difference between the Aid flow (current US$) in OECD members in 1985 and the Aid flow (current US$) in Sao Tome and Principe in 1987?
Make the answer very short. 9.59e+07. What is the difference between the Aid flow (current US$) in Sub-Saharan Africa (all income levels) in 1985 and the Aid flow (current US$) in Guinea in 1987?
Provide a succinct answer. 5.72e+08. What is the difference between the Aid flow (current US$) of Sub-Saharan Africa (all income levels) in 1985 and the Aid flow (current US$) of Sao Tome and Principe in 1987?
Give a very brief answer. 5.95e+08. What is the difference between the Aid flow (current US$) of Guinea in 1985 and the Aid flow (current US$) of Sao Tome and Principe in 1987?
Ensure brevity in your answer.  7.96e+06. What is the difference between the Aid flow (current US$) of OECD members in 1985 and the Aid flow (current US$) of Sub-Saharan Africa (all income levels) in 1988?
Provide a succinct answer. -8.85e+08. What is the difference between the Aid flow (current US$) in OECD members in 1985 and the Aid flow (current US$) in Guinea in 1988?
Your answer should be compact. 8.18e+07. What is the difference between the Aid flow (current US$) of OECD members in 1985 and the Aid flow (current US$) of Sao Tome and Principe in 1988?
Your answer should be compact. 9.57e+07. What is the difference between the Aid flow (current US$) of Sub-Saharan Africa (all income levels) in 1985 and the Aid flow (current US$) of Guinea in 1988?
Your answer should be very brief. 5.80e+08. What is the difference between the Aid flow (current US$) in Sub-Saharan Africa (all income levels) in 1985 and the Aid flow (current US$) in Sao Tome and Principe in 1988?
Keep it short and to the point. 5.94e+08. What is the difference between the Aid flow (current US$) in Guinea in 1985 and the Aid flow (current US$) in Sao Tome and Principe in 1988?
Offer a terse response. 7.71e+06. What is the difference between the Aid flow (current US$) of OECD members in 1986 and the Aid flow (current US$) of Sub-Saharan Africa (all income levels) in 1987?
Your response must be concise. -8.02e+08. What is the difference between the Aid flow (current US$) in OECD members in 1986 and the Aid flow (current US$) in Guinea in 1987?
Ensure brevity in your answer.  1.33e+08. What is the difference between the Aid flow (current US$) of OECD members in 1986 and the Aid flow (current US$) of Sao Tome and Principe in 1987?
Make the answer very short. 1.56e+08. What is the difference between the Aid flow (current US$) in Sub-Saharan Africa (all income levels) in 1986 and the Aid flow (current US$) in Guinea in 1987?
Your answer should be very brief. 7.64e+08. What is the difference between the Aid flow (current US$) of Sub-Saharan Africa (all income levels) in 1986 and the Aid flow (current US$) of Sao Tome and Principe in 1987?
Give a very brief answer. 7.87e+08. What is the difference between the Aid flow (current US$) in Guinea in 1986 and the Aid flow (current US$) in Sao Tome and Principe in 1987?
Your answer should be very brief. 1.29e+07. What is the difference between the Aid flow (current US$) in OECD members in 1986 and the Aid flow (current US$) in Sub-Saharan Africa (all income levels) in 1988?
Offer a very short reply. -8.25e+08. What is the difference between the Aid flow (current US$) of OECD members in 1986 and the Aid flow (current US$) of Guinea in 1988?
Offer a terse response. 1.41e+08. What is the difference between the Aid flow (current US$) of OECD members in 1986 and the Aid flow (current US$) of Sao Tome and Principe in 1988?
Give a very brief answer. 1.55e+08. What is the difference between the Aid flow (current US$) of Sub-Saharan Africa (all income levels) in 1986 and the Aid flow (current US$) of Guinea in 1988?
Provide a succinct answer. 7.73e+08. What is the difference between the Aid flow (current US$) in Sub-Saharan Africa (all income levels) in 1986 and the Aid flow (current US$) in Sao Tome and Principe in 1988?
Your response must be concise. 7.87e+08. What is the difference between the Aid flow (current US$) in Guinea in 1986 and the Aid flow (current US$) in Sao Tome and Principe in 1988?
Offer a very short reply. 1.27e+07. What is the difference between the Aid flow (current US$) in OECD members in 1987 and the Aid flow (current US$) in Sub-Saharan Africa (all income levels) in 1988?
Make the answer very short. -6.53e+08. What is the difference between the Aid flow (current US$) in OECD members in 1987 and the Aid flow (current US$) in Guinea in 1988?
Offer a terse response. 3.14e+08. What is the difference between the Aid flow (current US$) in OECD members in 1987 and the Aid flow (current US$) in Sao Tome and Principe in 1988?
Your answer should be very brief. 3.28e+08. What is the difference between the Aid flow (current US$) of Sub-Saharan Africa (all income levels) in 1987 and the Aid flow (current US$) of Guinea in 1988?
Ensure brevity in your answer.  9.44e+08. What is the difference between the Aid flow (current US$) in Sub-Saharan Africa (all income levels) in 1987 and the Aid flow (current US$) in Sao Tome and Principe in 1988?
Your response must be concise. 9.58e+08. What is the difference between the Aid flow (current US$) in Guinea in 1987 and the Aid flow (current US$) in Sao Tome and Principe in 1988?
Ensure brevity in your answer.  2.26e+07. What is the average Aid flow (current US$) of OECD members per year?
Your answer should be very brief. 2.44e+08. What is the average Aid flow (current US$) of Sub-Saharan Africa (all income levels) per year?
Make the answer very short. 7.34e+08. What is the average Aid flow (current US$) of Guinea per year?
Your answer should be very brief. 1.09e+07. What is the average Aid flow (current US$) of Sao Tome and Principe per year?
Provide a succinct answer. 1.61e+05. In the year 1979, what is the difference between the Aid flow (current US$) of OECD members and Aid flow (current US$) of Sub-Saharan Africa (all income levels)?
Your answer should be very brief. -2.87e+08. In the year 1979, what is the difference between the Aid flow (current US$) in OECD members and Aid flow (current US$) in Guinea?
Make the answer very short. 3.83e+08. In the year 1979, what is the difference between the Aid flow (current US$) in OECD members and Aid flow (current US$) in Sao Tome and Principe?
Give a very brief answer. 3.84e+08. In the year 1979, what is the difference between the Aid flow (current US$) in Sub-Saharan Africa (all income levels) and Aid flow (current US$) in Guinea?
Your answer should be very brief. 6.70e+08. In the year 1979, what is the difference between the Aid flow (current US$) in Sub-Saharan Africa (all income levels) and Aid flow (current US$) in Sao Tome and Principe?
Keep it short and to the point. 6.71e+08. In the year 1979, what is the difference between the Aid flow (current US$) of Guinea and Aid flow (current US$) of Sao Tome and Principe?
Your answer should be very brief. 9.60e+05. In the year 1980, what is the difference between the Aid flow (current US$) of OECD members and Aid flow (current US$) of Sub-Saharan Africa (all income levels)?
Your response must be concise. -1.91e+08. In the year 1980, what is the difference between the Aid flow (current US$) in OECD members and Aid flow (current US$) in Guinea?
Provide a short and direct response. 4.48e+08. In the year 1980, what is the difference between the Aid flow (current US$) of OECD members and Aid flow (current US$) of Sao Tome and Principe?
Your answer should be very brief. 4.60e+08. In the year 1980, what is the difference between the Aid flow (current US$) in Sub-Saharan Africa (all income levels) and Aid flow (current US$) in Guinea?
Your answer should be very brief. 6.39e+08. In the year 1980, what is the difference between the Aid flow (current US$) of Sub-Saharan Africa (all income levels) and Aid flow (current US$) of Sao Tome and Principe?
Provide a succinct answer. 6.51e+08. In the year 1980, what is the difference between the Aid flow (current US$) of Guinea and Aid flow (current US$) of Sao Tome and Principe?
Make the answer very short. 1.28e+07. In the year 1983, what is the difference between the Aid flow (current US$) in OECD members and Aid flow (current US$) in Sub-Saharan Africa (all income levels)?
Make the answer very short. -5.09e+08. In the year 1983, what is the difference between the Aid flow (current US$) of OECD members and Aid flow (current US$) of Guinea?
Offer a terse response. 1.50e+08. In the year 1983, what is the difference between the Aid flow (current US$) of OECD members and Aid flow (current US$) of Sao Tome and Principe?
Make the answer very short. 1.56e+08. In the year 1983, what is the difference between the Aid flow (current US$) in Sub-Saharan Africa (all income levels) and Aid flow (current US$) in Guinea?
Provide a succinct answer. 6.58e+08. In the year 1983, what is the difference between the Aid flow (current US$) of Sub-Saharan Africa (all income levels) and Aid flow (current US$) of Sao Tome and Principe?
Offer a very short reply. 6.65e+08. In the year 1983, what is the difference between the Aid flow (current US$) of Guinea and Aid flow (current US$) of Sao Tome and Principe?
Provide a short and direct response. 6.51e+06. In the year 1984, what is the difference between the Aid flow (current US$) of OECD members and Aid flow (current US$) of Sub-Saharan Africa (all income levels)?
Offer a terse response. -4.59e+08. In the year 1984, what is the difference between the Aid flow (current US$) of OECD members and Aid flow (current US$) of Guinea?
Your response must be concise. 9.93e+07. In the year 1984, what is the difference between the Aid flow (current US$) in OECD members and Aid flow (current US$) in Sao Tome and Principe?
Give a very brief answer. 1.08e+08. In the year 1984, what is the difference between the Aid flow (current US$) of Sub-Saharan Africa (all income levels) and Aid flow (current US$) of Guinea?
Offer a very short reply. 5.58e+08. In the year 1984, what is the difference between the Aid flow (current US$) of Sub-Saharan Africa (all income levels) and Aid flow (current US$) of Sao Tome and Principe?
Keep it short and to the point. 5.66e+08. In the year 1984, what is the difference between the Aid flow (current US$) in Guinea and Aid flow (current US$) in Sao Tome and Principe?
Provide a succinct answer. 8.21e+06. In the year 1985, what is the difference between the Aid flow (current US$) in OECD members and Aid flow (current US$) in Sub-Saharan Africa (all income levels)?
Provide a short and direct response. -4.99e+08. In the year 1985, what is the difference between the Aid flow (current US$) of OECD members and Aid flow (current US$) of Guinea?
Your answer should be compact. 8.80e+07. In the year 1985, what is the difference between the Aid flow (current US$) of OECD members and Aid flow (current US$) of Sao Tome and Principe?
Provide a short and direct response. 9.59e+07. In the year 1985, what is the difference between the Aid flow (current US$) of Sub-Saharan Africa (all income levels) and Aid flow (current US$) of Guinea?
Provide a short and direct response. 5.87e+08. In the year 1985, what is the difference between the Aid flow (current US$) of Sub-Saharan Africa (all income levels) and Aid flow (current US$) of Sao Tome and Principe?
Keep it short and to the point. 5.95e+08. In the year 1985, what is the difference between the Aid flow (current US$) in Guinea and Aid flow (current US$) in Sao Tome and Principe?
Make the answer very short. 7.92e+06. In the year 1986, what is the difference between the Aid flow (current US$) in OECD members and Aid flow (current US$) in Sub-Saharan Africa (all income levels)?
Offer a very short reply. -6.32e+08. In the year 1986, what is the difference between the Aid flow (current US$) of OECD members and Aid flow (current US$) of Guinea?
Your answer should be compact. 1.43e+08. In the year 1986, what is the difference between the Aid flow (current US$) of OECD members and Aid flow (current US$) of Sao Tome and Principe?
Offer a terse response. 1.55e+08. In the year 1986, what is the difference between the Aid flow (current US$) in Sub-Saharan Africa (all income levels) and Aid flow (current US$) in Guinea?
Give a very brief answer. 7.74e+08. In the year 1986, what is the difference between the Aid flow (current US$) in Sub-Saharan Africa (all income levels) and Aid flow (current US$) in Sao Tome and Principe?
Make the answer very short. 7.87e+08. In the year 1986, what is the difference between the Aid flow (current US$) in Guinea and Aid flow (current US$) in Sao Tome and Principe?
Offer a very short reply. 1.27e+07. In the year 1987, what is the difference between the Aid flow (current US$) in OECD members and Aid flow (current US$) in Sub-Saharan Africa (all income levels)?
Give a very brief answer. -6.30e+08. In the year 1987, what is the difference between the Aid flow (current US$) of OECD members and Aid flow (current US$) of Guinea?
Provide a short and direct response. 3.05e+08. In the year 1987, what is the difference between the Aid flow (current US$) in OECD members and Aid flow (current US$) in Sao Tome and Principe?
Offer a terse response. 3.28e+08. In the year 1987, what is the difference between the Aid flow (current US$) in Sub-Saharan Africa (all income levels) and Aid flow (current US$) in Guinea?
Keep it short and to the point. 9.35e+08. In the year 1987, what is the difference between the Aid flow (current US$) in Sub-Saharan Africa (all income levels) and Aid flow (current US$) in Sao Tome and Principe?
Provide a succinct answer. 9.58e+08. In the year 1987, what is the difference between the Aid flow (current US$) in Guinea and Aid flow (current US$) in Sao Tome and Principe?
Offer a terse response. 2.29e+07. In the year 1988, what is the difference between the Aid flow (current US$) of OECD members and Aid flow (current US$) of Sub-Saharan Africa (all income levels)?
Your response must be concise. -7.16e+08. In the year 1988, what is the difference between the Aid flow (current US$) in OECD members and Aid flow (current US$) in Guinea?
Provide a short and direct response. 2.51e+08. In the year 1988, what is the difference between the Aid flow (current US$) of OECD members and Aid flow (current US$) of Sao Tome and Principe?
Ensure brevity in your answer.  2.65e+08. In the year 1988, what is the difference between the Aid flow (current US$) of Sub-Saharan Africa (all income levels) and Aid flow (current US$) of Guinea?
Offer a terse response. 9.67e+08. In the year 1988, what is the difference between the Aid flow (current US$) of Sub-Saharan Africa (all income levels) and Aid flow (current US$) of Sao Tome and Principe?
Offer a terse response. 9.81e+08. In the year 1988, what is the difference between the Aid flow (current US$) of Guinea and Aid flow (current US$) of Sao Tome and Principe?
Your answer should be very brief. 1.39e+07. What is the ratio of the Aid flow (current US$) in OECD members in 1979 to that in 1980?
Give a very brief answer. 0.83. What is the ratio of the Aid flow (current US$) in Sub-Saharan Africa (all income levels) in 1979 to that in 1980?
Offer a terse response. 1.03. What is the ratio of the Aid flow (current US$) of Guinea in 1979 to that in 1980?
Provide a short and direct response. 0.08. What is the ratio of the Aid flow (current US$) in Sao Tome and Principe in 1979 to that in 1980?
Keep it short and to the point. 0.67. What is the ratio of the Aid flow (current US$) of OECD members in 1979 to that in 1983?
Give a very brief answer. 2.45. What is the ratio of the Aid flow (current US$) of Sub-Saharan Africa (all income levels) in 1979 to that in 1983?
Your answer should be very brief. 1.01. What is the ratio of the Aid flow (current US$) of Guinea in 1979 to that in 1983?
Offer a terse response. 0.15. What is the ratio of the Aid flow (current US$) of Sao Tome and Principe in 1979 to that in 1983?
Provide a short and direct response. 0.18. What is the ratio of the Aid flow (current US$) of OECD members in 1979 to that in 1984?
Ensure brevity in your answer.  3.56. What is the ratio of the Aid flow (current US$) of Sub-Saharan Africa (all income levels) in 1979 to that in 1984?
Give a very brief answer. 1.19. What is the ratio of the Aid flow (current US$) in Guinea in 1979 to that in 1984?
Offer a very short reply. 0.12. What is the ratio of the Aid flow (current US$) of Sao Tome and Principe in 1979 to that in 1984?
Offer a very short reply. 0.16. What is the ratio of the Aid flow (current US$) in OECD members in 1979 to that in 1985?
Your answer should be compact. 4. What is the ratio of the Aid flow (current US$) in Sub-Saharan Africa (all income levels) in 1979 to that in 1985?
Offer a very short reply. 1.13. What is the ratio of the Aid flow (current US$) of Guinea in 1979 to that in 1985?
Keep it short and to the point. 0.12. What is the ratio of the Aid flow (current US$) in Sao Tome and Principe in 1979 to that in 1985?
Provide a succinct answer. 0.44. What is the ratio of the Aid flow (current US$) of OECD members in 1979 to that in 1986?
Your answer should be very brief. 2.47. What is the ratio of the Aid flow (current US$) in Sub-Saharan Africa (all income levels) in 1979 to that in 1986?
Make the answer very short. 0.85. What is the ratio of the Aid flow (current US$) of Guinea in 1979 to that in 1986?
Your response must be concise. 0.08. What is the ratio of the Aid flow (current US$) in Sao Tome and Principe in 1979 to that in 1986?
Your answer should be compact. 0.14. What is the ratio of the Aid flow (current US$) of OECD members in 1979 to that in 1987?
Offer a terse response. 1.17. What is the ratio of the Aid flow (current US$) of Sub-Saharan Africa (all income levels) in 1979 to that in 1987?
Give a very brief answer. 0.7. What is the ratio of the Aid flow (current US$) in Guinea in 1979 to that in 1987?
Offer a terse response. 0.04. What is the ratio of the Aid flow (current US$) of OECD members in 1979 to that in 1988?
Offer a terse response. 1.45. What is the ratio of the Aid flow (current US$) of Sub-Saharan Africa (all income levels) in 1979 to that in 1988?
Provide a short and direct response. 0.68. What is the ratio of the Aid flow (current US$) of Guinea in 1979 to that in 1988?
Keep it short and to the point. 0.07. What is the ratio of the Aid flow (current US$) of Sao Tome and Principe in 1979 to that in 1988?
Provide a short and direct response. 0.13. What is the ratio of the Aid flow (current US$) in OECD members in 1980 to that in 1983?
Offer a terse response. 2.94. What is the ratio of the Aid flow (current US$) in Sub-Saharan Africa (all income levels) in 1980 to that in 1983?
Provide a succinct answer. 0.98. What is the ratio of the Aid flow (current US$) of Guinea in 1980 to that in 1983?
Your answer should be very brief. 1.91. What is the ratio of the Aid flow (current US$) in Sao Tome and Principe in 1980 to that in 1983?
Keep it short and to the point. 0.27. What is the ratio of the Aid flow (current US$) in OECD members in 1980 to that in 1984?
Offer a terse response. 4.27. What is the ratio of the Aid flow (current US$) of Sub-Saharan Africa (all income levels) in 1980 to that in 1984?
Provide a short and direct response. 1.15. What is the ratio of the Aid flow (current US$) of Guinea in 1980 to that in 1984?
Offer a terse response. 1.52. What is the ratio of the Aid flow (current US$) in Sao Tome and Principe in 1980 to that in 1984?
Your answer should be very brief. 0.24. What is the ratio of the Aid flow (current US$) in OECD members in 1980 to that in 1985?
Make the answer very short. 4.8. What is the ratio of the Aid flow (current US$) of Sub-Saharan Africa (all income levels) in 1980 to that in 1985?
Give a very brief answer. 1.1. What is the ratio of the Aid flow (current US$) of Guinea in 1980 to that in 1985?
Your response must be concise. 1.6. What is the ratio of the Aid flow (current US$) in OECD members in 1980 to that in 1986?
Your answer should be compact. 2.96. What is the ratio of the Aid flow (current US$) of Sub-Saharan Africa (all income levels) in 1980 to that in 1986?
Ensure brevity in your answer.  0.83. What is the ratio of the Aid flow (current US$) in Sao Tome and Principe in 1980 to that in 1986?
Make the answer very short. 0.21. What is the ratio of the Aid flow (current US$) of OECD members in 1980 to that in 1987?
Make the answer very short. 1.4. What is the ratio of the Aid flow (current US$) in Sub-Saharan Africa (all income levels) in 1980 to that in 1987?
Offer a very short reply. 0.68. What is the ratio of the Aid flow (current US$) in Guinea in 1980 to that in 1987?
Your answer should be compact. 0.56. What is the ratio of the Aid flow (current US$) in Sao Tome and Principe in 1980 to that in 1987?
Your answer should be very brief. 1.2. What is the ratio of the Aid flow (current US$) of OECD members in 1980 to that in 1988?
Your answer should be very brief. 1.74. What is the ratio of the Aid flow (current US$) in Sub-Saharan Africa (all income levels) in 1980 to that in 1988?
Keep it short and to the point. 0.66. What is the ratio of the Aid flow (current US$) in Guinea in 1980 to that in 1988?
Provide a short and direct response. 0.9. What is the ratio of the Aid flow (current US$) in Sao Tome and Principe in 1980 to that in 1988?
Ensure brevity in your answer.  0.2. What is the ratio of the Aid flow (current US$) in OECD members in 1983 to that in 1984?
Offer a very short reply. 1.45. What is the ratio of the Aid flow (current US$) of Sub-Saharan Africa (all income levels) in 1983 to that in 1984?
Make the answer very short. 1.17. What is the ratio of the Aid flow (current US$) in Guinea in 1983 to that in 1984?
Your answer should be very brief. 0.8. What is the ratio of the Aid flow (current US$) of OECD members in 1983 to that in 1985?
Offer a very short reply. 1.63. What is the ratio of the Aid flow (current US$) in Sub-Saharan Africa (all income levels) in 1983 to that in 1985?
Offer a terse response. 1.12. What is the ratio of the Aid flow (current US$) in Guinea in 1983 to that in 1985?
Ensure brevity in your answer.  0.84. What is the ratio of the Aid flow (current US$) in Sao Tome and Principe in 1983 to that in 1985?
Your answer should be compact. 2.44. What is the ratio of the Aid flow (current US$) in OECD members in 1983 to that in 1986?
Keep it short and to the point. 1.01. What is the ratio of the Aid flow (current US$) of Sub-Saharan Africa (all income levels) in 1983 to that in 1986?
Provide a succinct answer. 0.84. What is the ratio of the Aid flow (current US$) of Guinea in 1983 to that in 1986?
Your answer should be very brief. 0.52. What is the ratio of the Aid flow (current US$) in Sao Tome and Principe in 1983 to that in 1986?
Your response must be concise. 0.79. What is the ratio of the Aid flow (current US$) of OECD members in 1983 to that in 1987?
Offer a terse response. 0.48. What is the ratio of the Aid flow (current US$) of Sub-Saharan Africa (all income levels) in 1983 to that in 1987?
Make the answer very short. 0.69. What is the ratio of the Aid flow (current US$) in Guinea in 1983 to that in 1987?
Offer a very short reply. 0.29. What is the ratio of the Aid flow (current US$) in OECD members in 1983 to that in 1988?
Provide a succinct answer. 0.59. What is the ratio of the Aid flow (current US$) in Sub-Saharan Africa (all income levels) in 1983 to that in 1988?
Make the answer very short. 0.68. What is the ratio of the Aid flow (current US$) of Guinea in 1983 to that in 1988?
Provide a succinct answer. 0.47. What is the ratio of the Aid flow (current US$) of Sao Tome and Principe in 1983 to that in 1988?
Keep it short and to the point. 0.73. What is the ratio of the Aid flow (current US$) of OECD members in 1984 to that in 1985?
Provide a short and direct response. 1.12. What is the ratio of the Aid flow (current US$) in Sub-Saharan Africa (all income levels) in 1984 to that in 1985?
Make the answer very short. 0.95. What is the ratio of the Aid flow (current US$) of Guinea in 1984 to that in 1985?
Provide a succinct answer. 1.06. What is the ratio of the Aid flow (current US$) in Sao Tome and Principe in 1984 to that in 1985?
Provide a succinct answer. 2.78. What is the ratio of the Aid flow (current US$) in OECD members in 1984 to that in 1986?
Your answer should be very brief. 0.69. What is the ratio of the Aid flow (current US$) in Sub-Saharan Africa (all income levels) in 1984 to that in 1986?
Offer a terse response. 0.72. What is the ratio of the Aid flow (current US$) of Guinea in 1984 to that in 1986?
Give a very brief answer. 0.65. What is the ratio of the Aid flow (current US$) of Sao Tome and Principe in 1984 to that in 1986?
Offer a terse response. 0.89. What is the ratio of the Aid flow (current US$) in OECD members in 1984 to that in 1987?
Offer a very short reply. 0.33. What is the ratio of the Aid flow (current US$) in Sub-Saharan Africa (all income levels) in 1984 to that in 1987?
Provide a succinct answer. 0.59. What is the ratio of the Aid flow (current US$) of Guinea in 1984 to that in 1987?
Your answer should be very brief. 0.37. What is the ratio of the Aid flow (current US$) of OECD members in 1984 to that in 1988?
Your answer should be very brief. 0.41. What is the ratio of the Aid flow (current US$) of Sub-Saharan Africa (all income levels) in 1984 to that in 1988?
Your answer should be very brief. 0.58. What is the ratio of the Aid flow (current US$) in Guinea in 1984 to that in 1988?
Give a very brief answer. 0.6. What is the ratio of the Aid flow (current US$) of OECD members in 1985 to that in 1986?
Offer a very short reply. 0.62. What is the ratio of the Aid flow (current US$) in Sub-Saharan Africa (all income levels) in 1985 to that in 1986?
Offer a terse response. 0.76. What is the ratio of the Aid flow (current US$) in Guinea in 1985 to that in 1986?
Provide a succinct answer. 0.62. What is the ratio of the Aid flow (current US$) of Sao Tome and Principe in 1985 to that in 1986?
Make the answer very short. 0.32. What is the ratio of the Aid flow (current US$) of OECD members in 1985 to that in 1987?
Offer a very short reply. 0.29. What is the ratio of the Aid flow (current US$) of Sub-Saharan Africa (all income levels) in 1985 to that in 1987?
Keep it short and to the point. 0.62. What is the ratio of the Aid flow (current US$) in Guinea in 1985 to that in 1987?
Ensure brevity in your answer.  0.35. What is the ratio of the Aid flow (current US$) in OECD members in 1985 to that in 1988?
Your answer should be very brief. 0.36. What is the ratio of the Aid flow (current US$) in Sub-Saharan Africa (all income levels) in 1985 to that in 1988?
Your response must be concise. 0.61. What is the ratio of the Aid flow (current US$) of Guinea in 1985 to that in 1988?
Provide a short and direct response. 0.56. What is the ratio of the Aid flow (current US$) in OECD members in 1986 to that in 1987?
Make the answer very short. 0.47. What is the ratio of the Aid flow (current US$) in Sub-Saharan Africa (all income levels) in 1986 to that in 1987?
Provide a short and direct response. 0.82. What is the ratio of the Aid flow (current US$) in Guinea in 1986 to that in 1987?
Provide a short and direct response. 0.57. What is the ratio of the Aid flow (current US$) of OECD members in 1986 to that in 1988?
Offer a terse response. 0.59. What is the ratio of the Aid flow (current US$) of Sub-Saharan Africa (all income levels) in 1986 to that in 1988?
Your answer should be very brief. 0.8. What is the ratio of the Aid flow (current US$) of Guinea in 1986 to that in 1988?
Offer a terse response. 0.91. What is the ratio of the Aid flow (current US$) of OECD members in 1987 to that in 1988?
Your answer should be very brief. 1.24. What is the ratio of the Aid flow (current US$) in Sub-Saharan Africa (all income levels) in 1987 to that in 1988?
Provide a short and direct response. 0.98. What is the ratio of the Aid flow (current US$) of Guinea in 1987 to that in 1988?
Provide a short and direct response. 1.61. What is the ratio of the Aid flow (current US$) of Sao Tome and Principe in 1987 to that in 1988?
Offer a terse response. 0.17. What is the difference between the highest and the second highest Aid flow (current US$) of OECD members?
Your answer should be compact. 7.64e+07. What is the difference between the highest and the second highest Aid flow (current US$) of Sub-Saharan Africa (all income levels)?
Your response must be concise. 2.31e+07. What is the difference between the highest and the second highest Aid flow (current US$) of Guinea?
Your response must be concise. 8.72e+06. What is the difference between the highest and the second highest Aid flow (current US$) in Sao Tome and Principe?
Keep it short and to the point. 2.00e+04. What is the difference between the highest and the lowest Aid flow (current US$) in OECD members?
Offer a terse response. 3.65e+08. What is the difference between the highest and the lowest Aid flow (current US$) of Sub-Saharan Africa (all income levels)?
Provide a succinct answer. 4.15e+08. What is the difference between the highest and the lowest Aid flow (current US$) of Guinea?
Make the answer very short. 2.19e+07. 